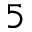<formula> <loc_0><loc_0><loc_500><loc_500>^ { 5 }</formula> 